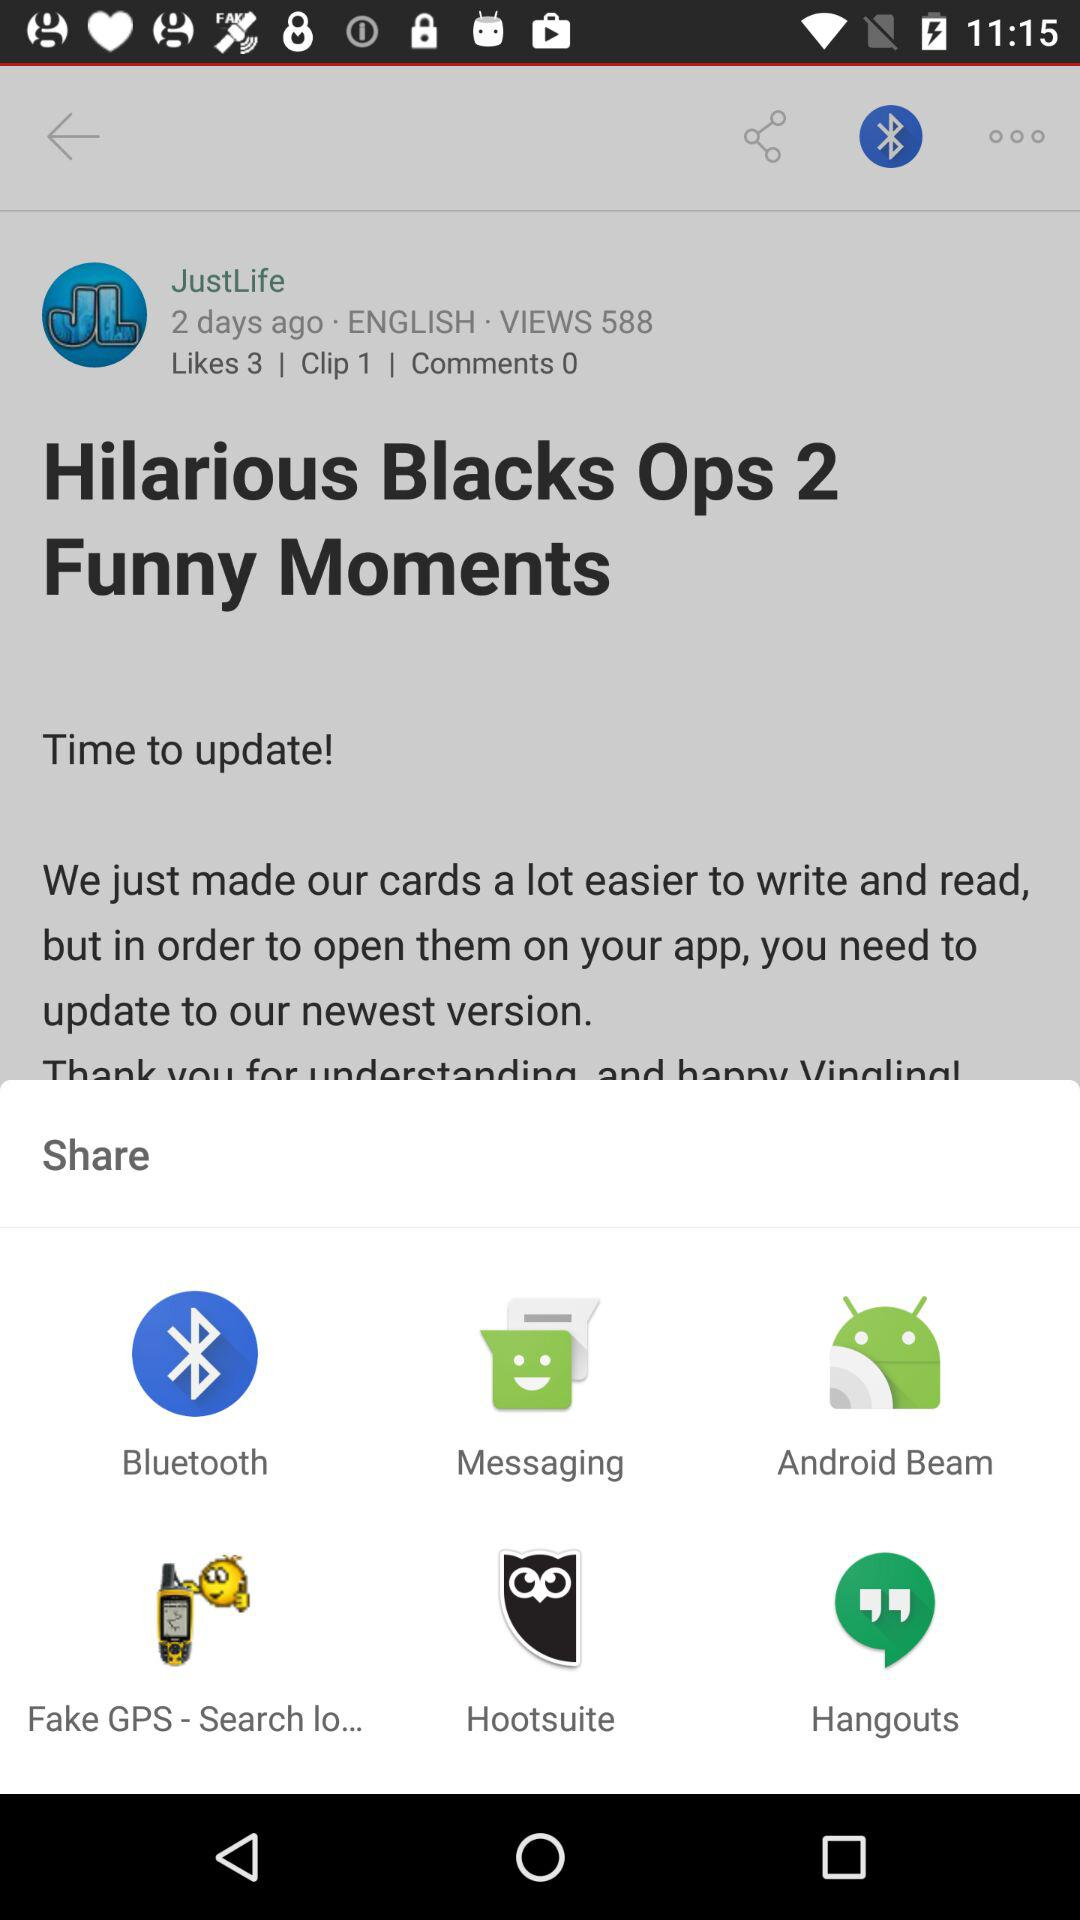Which sharing options are given? The sharing options are "Bluetooth", "Messaging", "Android Beam", "Fake GPS - Search lo...", "Hootsuite" and "Hangouts". 